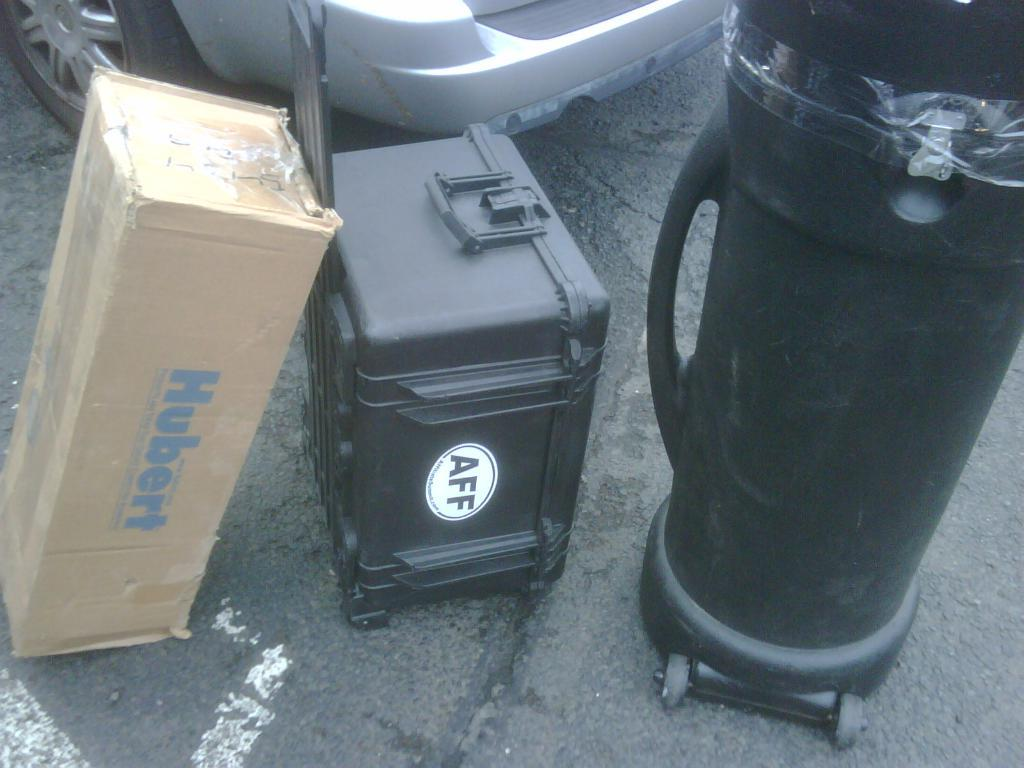<image>
Offer a succinct explanation of the picture presented. A cardboard box that says Hubert on it next to a gear case with a sticker reading AFF. 